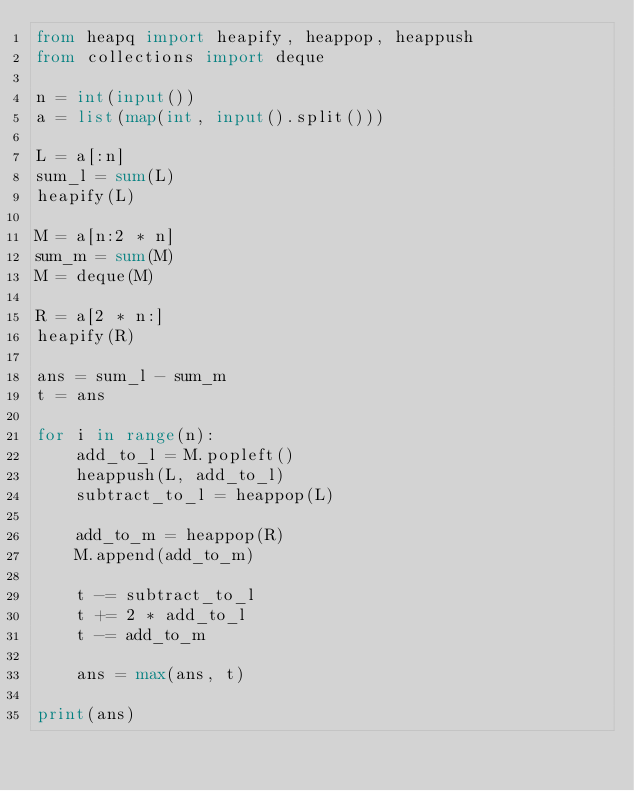Convert code to text. <code><loc_0><loc_0><loc_500><loc_500><_Python_>from heapq import heapify, heappop, heappush
from collections import deque

n = int(input())
a = list(map(int, input().split()))

L = a[:n]
sum_l = sum(L)
heapify(L)

M = a[n:2 * n]
sum_m = sum(M)
M = deque(M)

R = a[2 * n:]
heapify(R)

ans = sum_l - sum_m
t = ans

for i in range(n):
    add_to_l = M.popleft()
    heappush(L, add_to_l)
    subtract_to_l = heappop(L)
    
    add_to_m = heappop(R)
    M.append(add_to_m)

    t -= subtract_to_l
    t += 2 * add_to_l
    t -= add_to_m

    ans = max(ans, t)

print(ans)</code> 